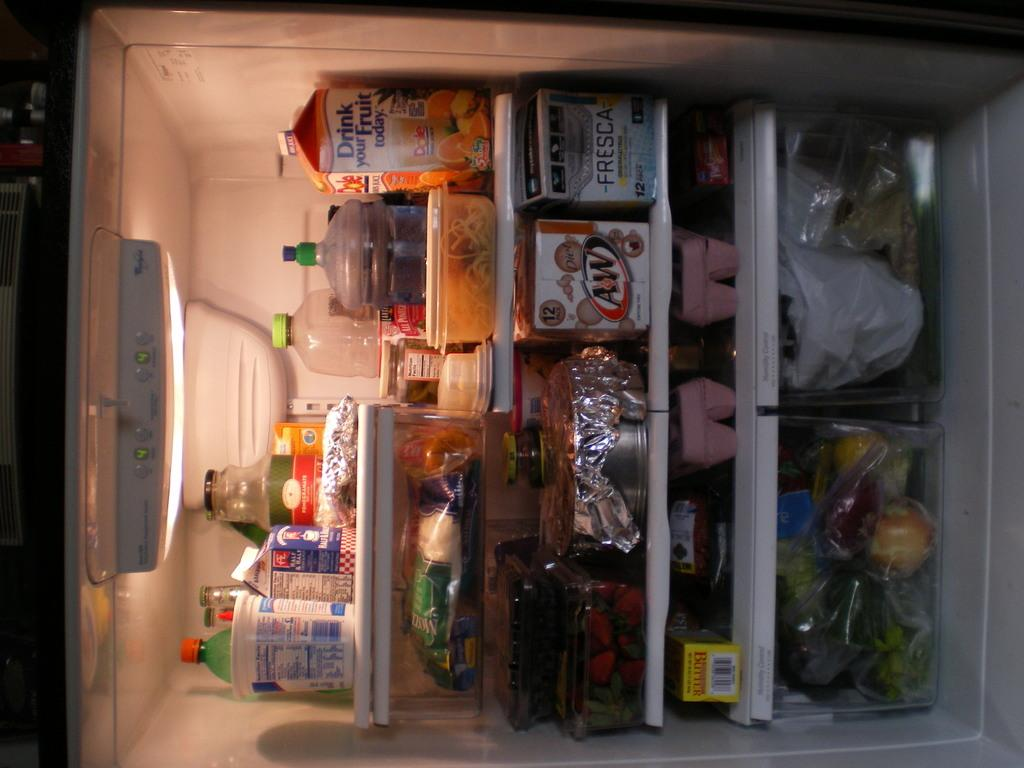<image>
Present a compact description of the photo's key features. A fridge full of products like fresca and root beer 